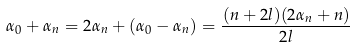<formula> <loc_0><loc_0><loc_500><loc_500>\alpha _ { 0 } + \alpha _ { n } = 2 \alpha _ { n } + ( \alpha _ { 0 } - \alpha _ { n } ) = \frac { ( n + 2 l ) ( 2 \alpha _ { n } + n ) } { 2 l }</formula> 